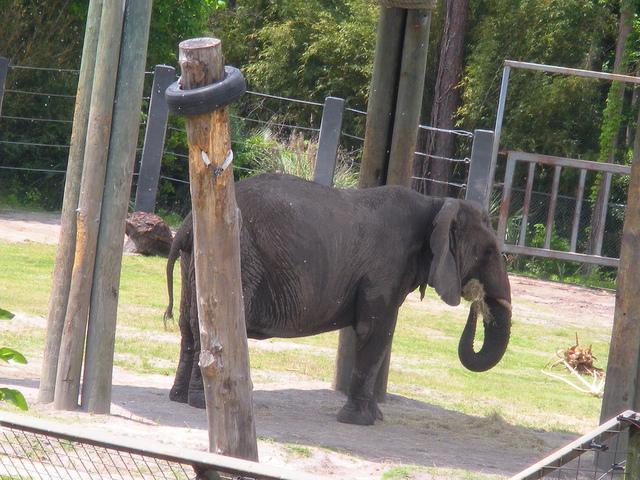How many logs are there?
Give a very brief answer. 1. How many people are in this photo?
Give a very brief answer. 0. 